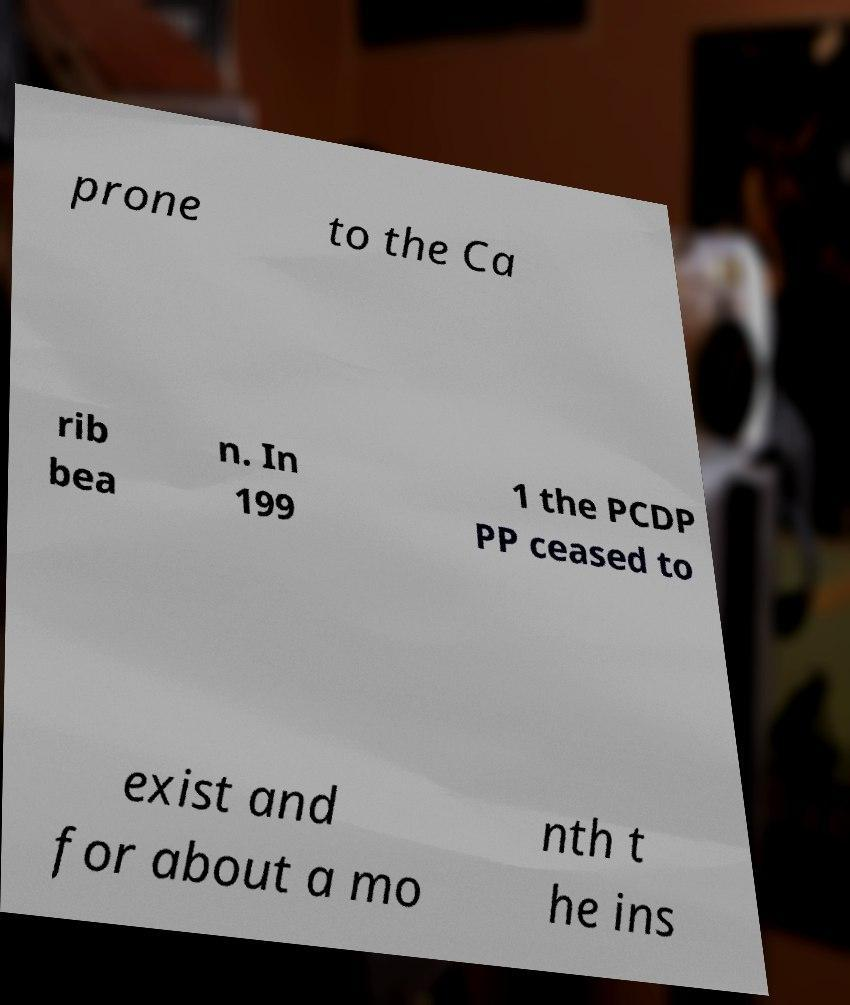For documentation purposes, I need the text within this image transcribed. Could you provide that? prone to the Ca rib bea n. In 199 1 the PCDP PP ceased to exist and for about a mo nth t he ins 